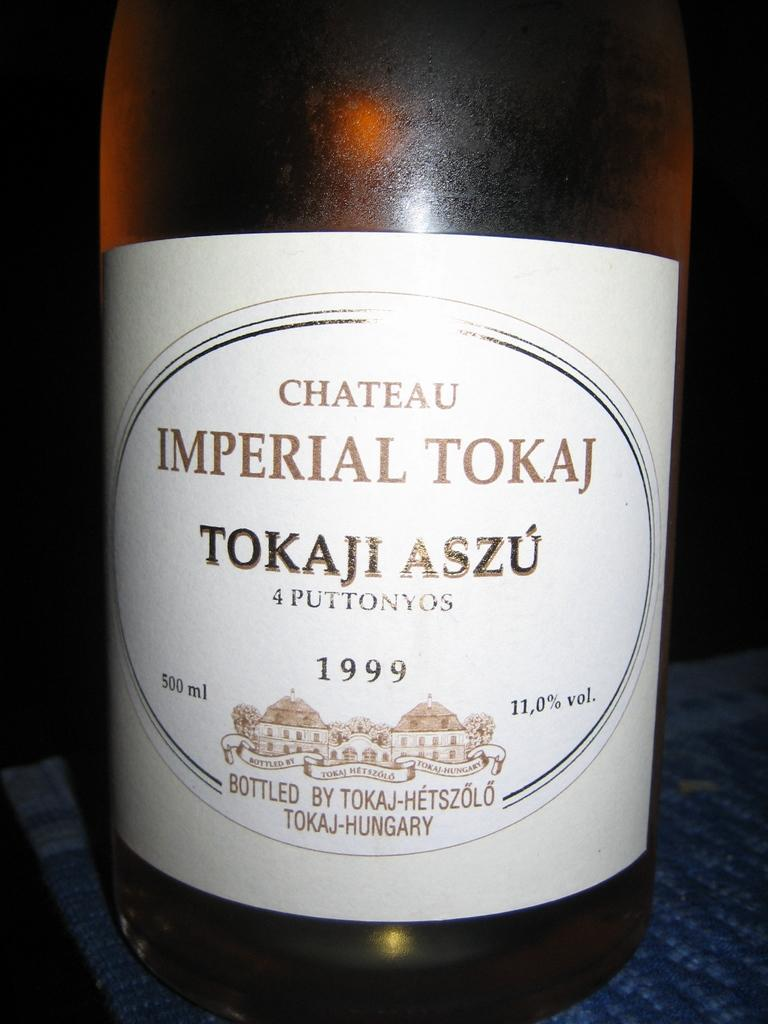Provide a one-sentence caption for the provided image. A bottle of wine which has Chateau Imperial Tokaj on the label. 